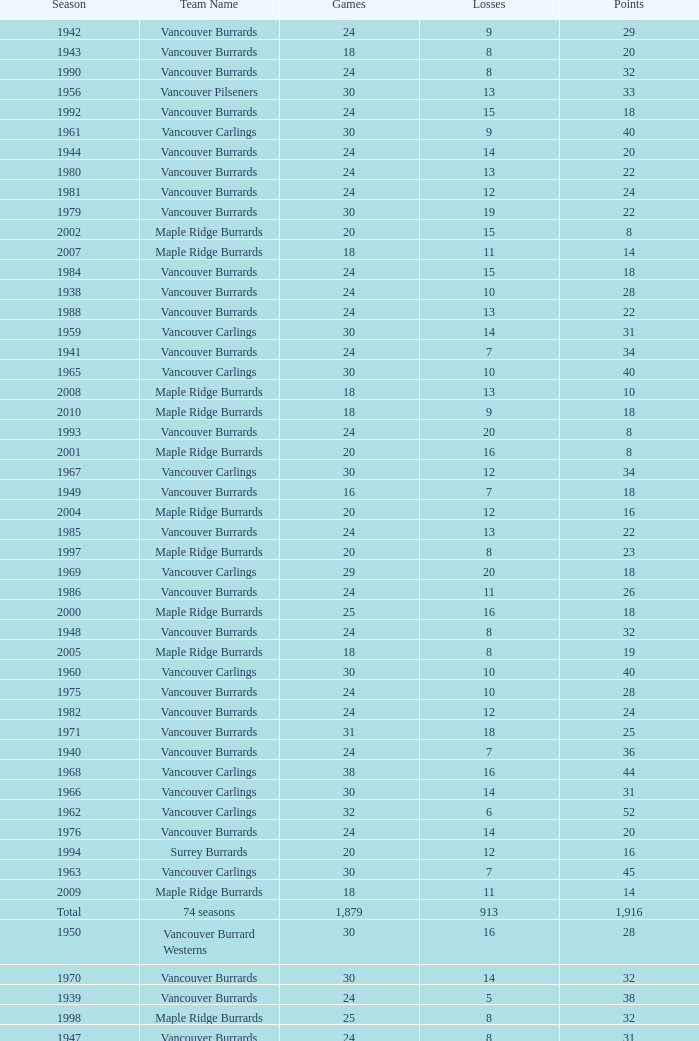What's the total number of points when the vancouver burrards have fewer than 9 losses and more than 24 games? 1.0. 